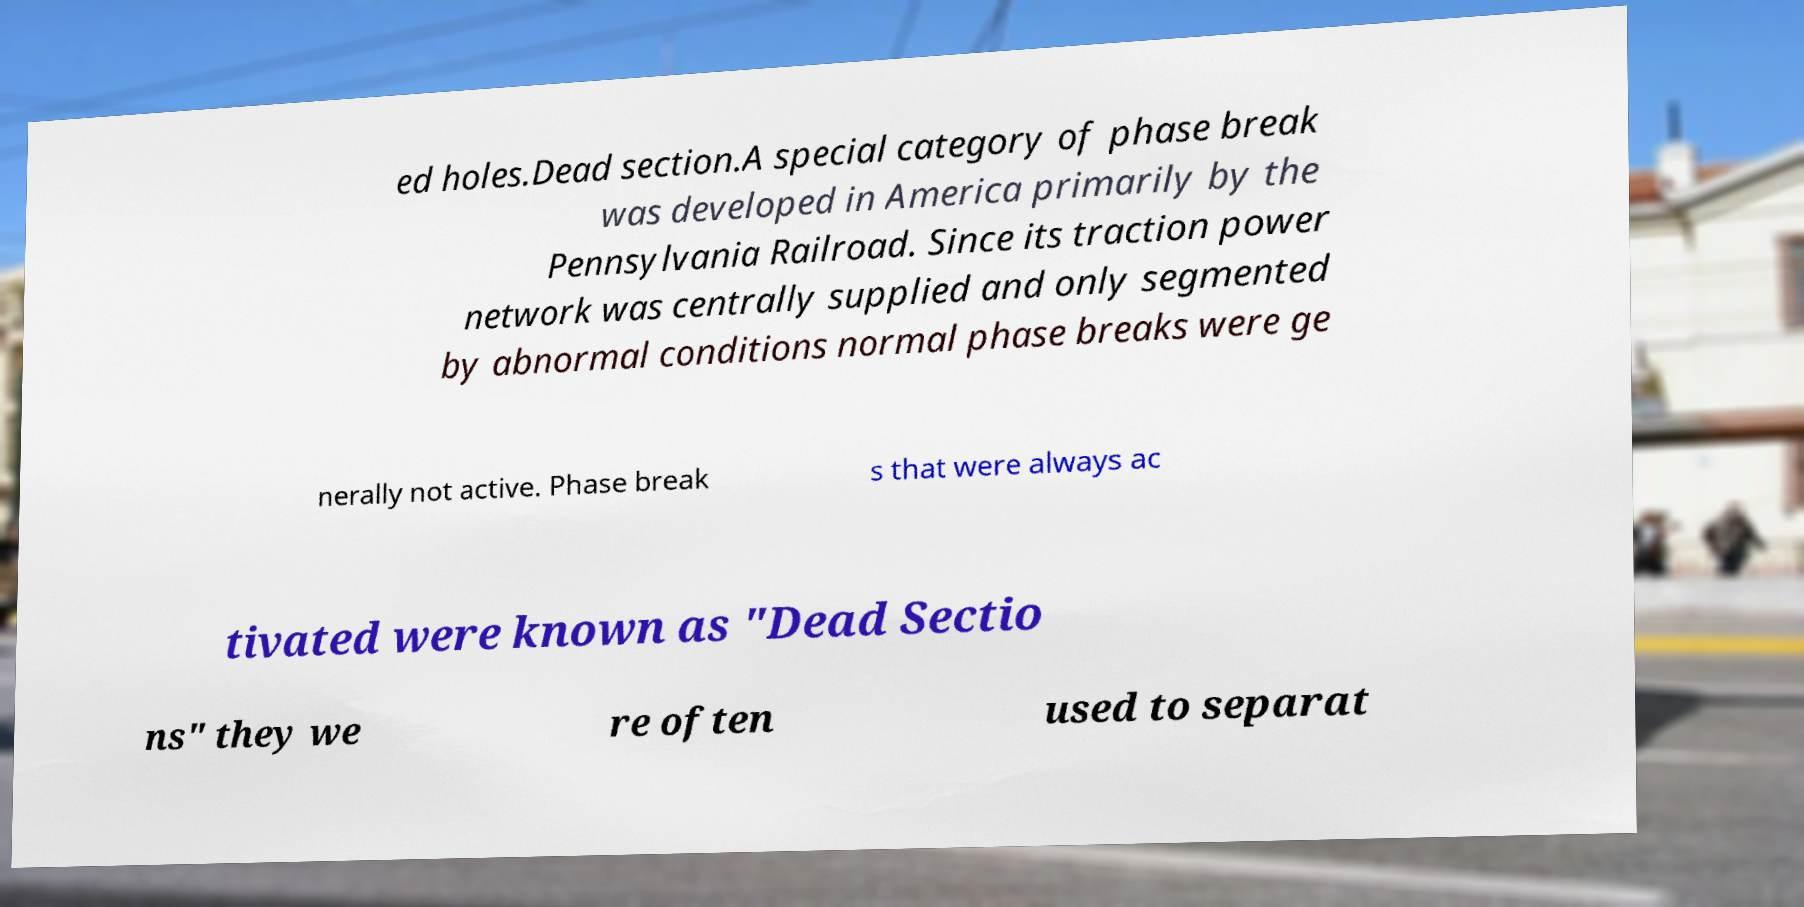For documentation purposes, I need the text within this image transcribed. Could you provide that? ed holes.Dead section.A special category of phase break was developed in America primarily by the Pennsylvania Railroad. Since its traction power network was centrally supplied and only segmented by abnormal conditions normal phase breaks were ge nerally not active. Phase break s that were always ac tivated were known as "Dead Sectio ns" they we re often used to separat 